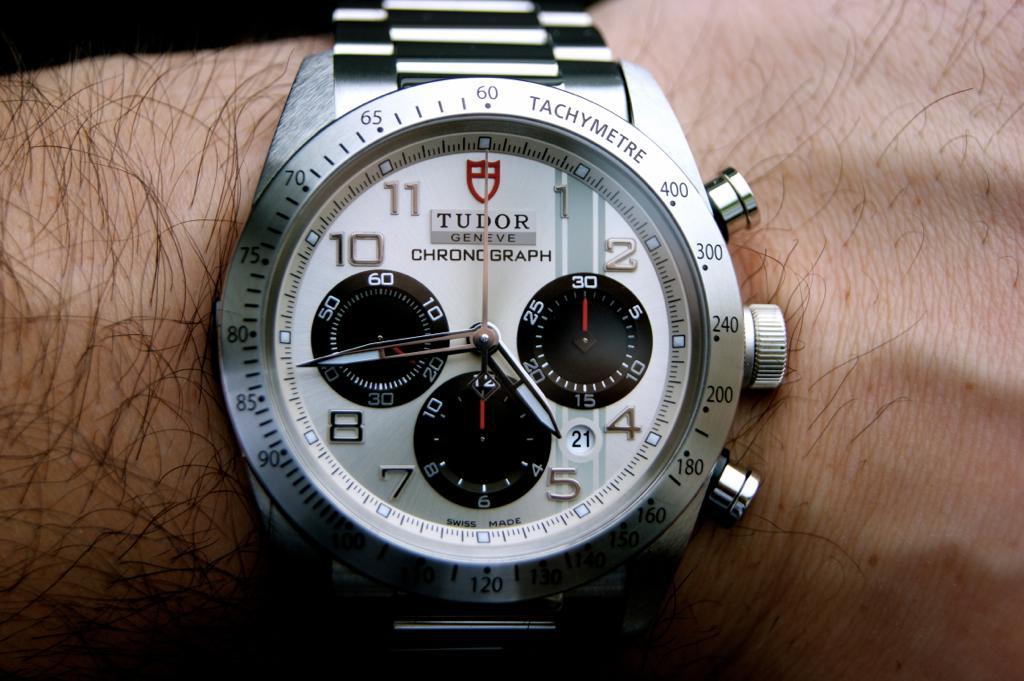What brand is this watch?
Provide a succinct answer. Tudor. What is the model name of the watch?
Give a very brief answer. Tudor. 